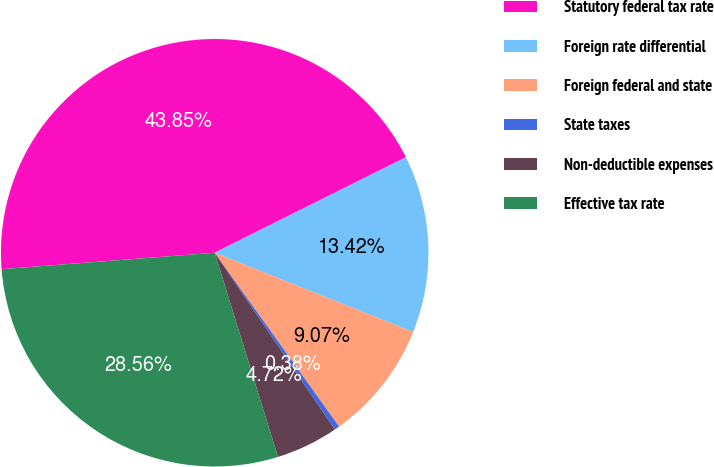<chart> <loc_0><loc_0><loc_500><loc_500><pie_chart><fcel>Statutory federal tax rate<fcel>Foreign rate differential<fcel>Foreign federal and state<fcel>State taxes<fcel>Non-deductible expenses<fcel>Effective tax rate<nl><fcel>43.85%<fcel>13.42%<fcel>9.07%<fcel>0.38%<fcel>4.72%<fcel>28.56%<nl></chart> 